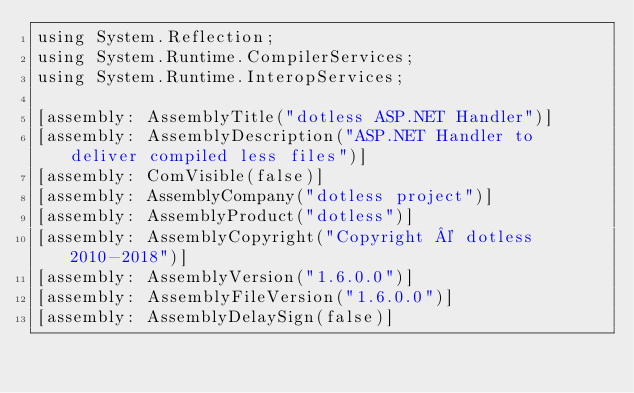Convert code to text. <code><loc_0><loc_0><loc_500><loc_500><_C#_>using System.Reflection;
using System.Runtime.CompilerServices;
using System.Runtime.InteropServices;

[assembly: AssemblyTitle("dotless ASP.NET Handler")]
[assembly: AssemblyDescription("ASP.NET Handler to deliver compiled less files")]
[assembly: ComVisible(false)]
[assembly: AssemblyCompany("dotless project")]
[assembly: AssemblyProduct("dotless")]
[assembly: AssemblyCopyright("Copyright © dotless 2010-2018")]
[assembly: AssemblyVersion("1.6.0.0")]
[assembly: AssemblyFileVersion("1.6.0.0")]
[assembly: AssemblyDelaySign(false)]</code> 